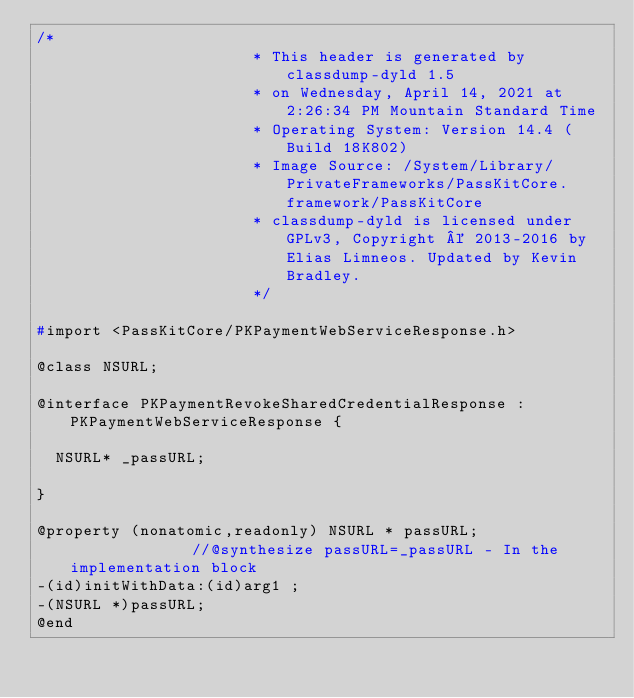Convert code to text. <code><loc_0><loc_0><loc_500><loc_500><_C_>/*
                       * This header is generated by classdump-dyld 1.5
                       * on Wednesday, April 14, 2021 at 2:26:34 PM Mountain Standard Time
                       * Operating System: Version 14.4 (Build 18K802)
                       * Image Source: /System/Library/PrivateFrameworks/PassKitCore.framework/PassKitCore
                       * classdump-dyld is licensed under GPLv3, Copyright © 2013-2016 by Elias Limneos. Updated by Kevin Bradley.
                       */

#import <PassKitCore/PKPaymentWebServiceResponse.h>

@class NSURL;

@interface PKPaymentRevokeSharedCredentialResponse : PKPaymentWebServiceResponse {

	NSURL* _passURL;

}

@property (nonatomic,readonly) NSURL * passURL;              //@synthesize passURL=_passURL - In the implementation block
-(id)initWithData:(id)arg1 ;
-(NSURL *)passURL;
@end

</code> 